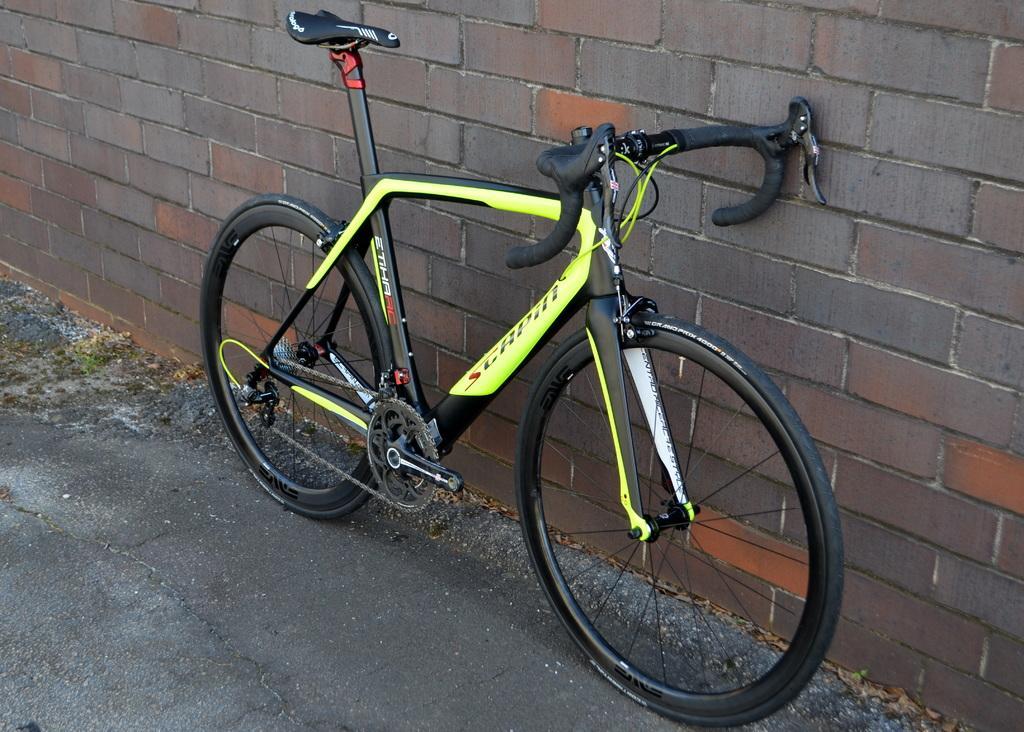Please provide a concise description of this image. Here we can see a bicycle. In the background there is a wall. 